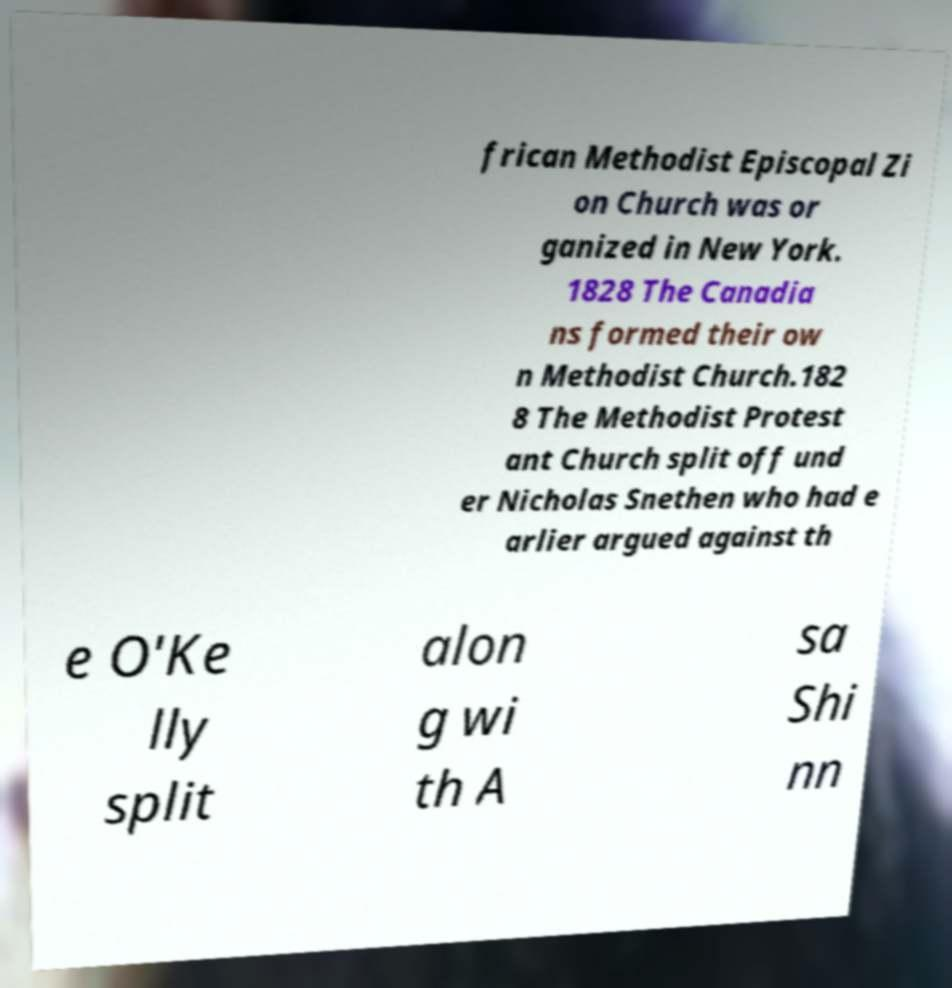Could you assist in decoding the text presented in this image and type it out clearly? frican Methodist Episcopal Zi on Church was or ganized in New York. 1828 The Canadia ns formed their ow n Methodist Church.182 8 The Methodist Protest ant Church split off und er Nicholas Snethen who had e arlier argued against th e O'Ke lly split alon g wi th A sa Shi nn 